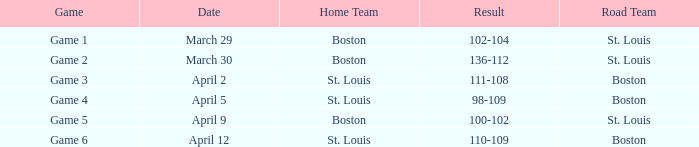On what Date is Game 3 with Boston Road Team? April 2. 